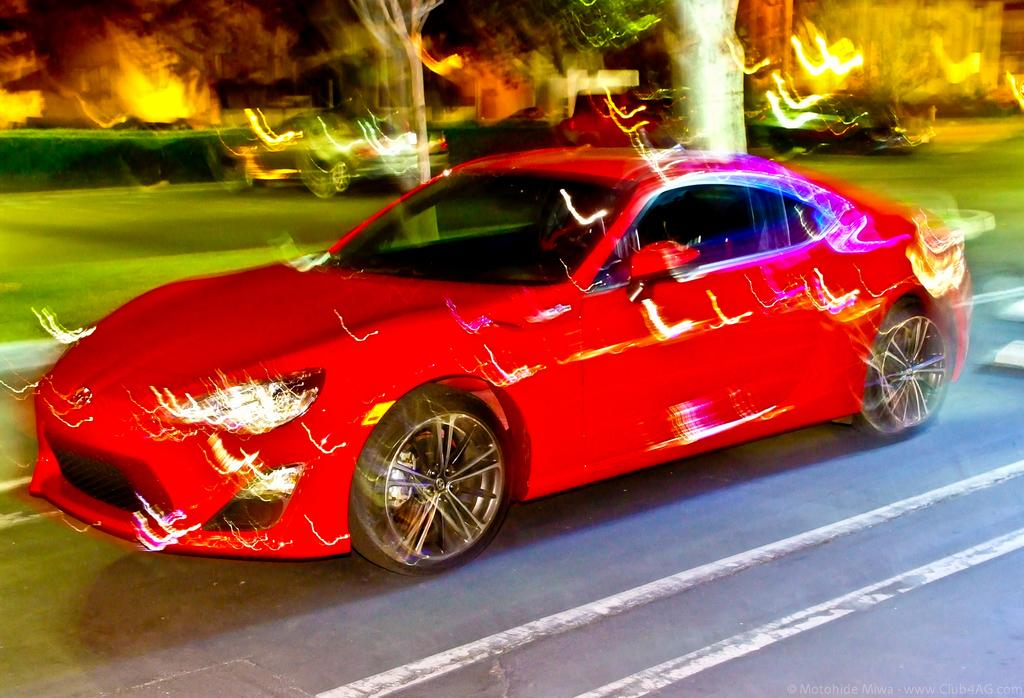What color is the car that is visible on the road in the image? The car is red. What else can be seen on the road besides the red car? There are other vehicles visible in the image. What type of natural elements can be seen in the image? There are trees and grass visible in the image. What type of man-made structures can be seen in the image? There are buildings visible in the image. What is the primary surface on which the vehicles are traveling in the image? There is a road in the image. What type of powder is being used to clean the windows of the buildings in the image? There is no indication of any cleaning activity or powder in the image. 